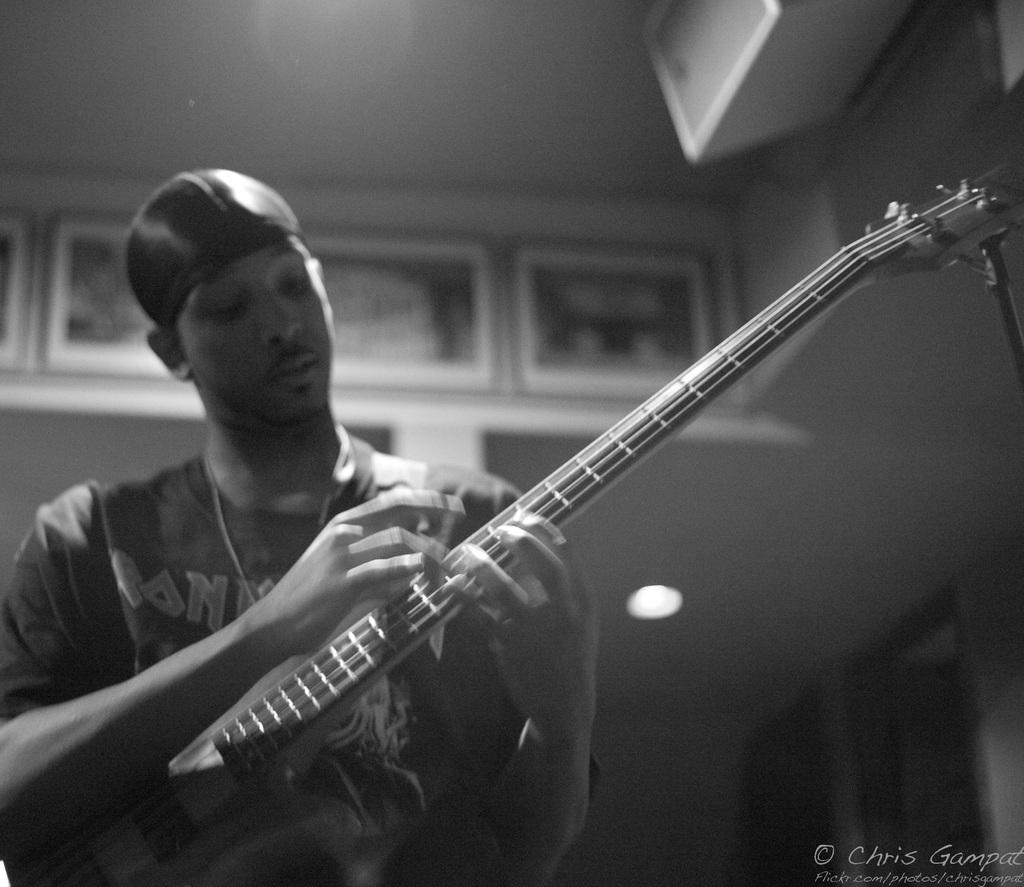What is the person in the image doing? The person is playing the guitar. What object is the person holding while playing the guitar? The person is holding a guitar. What type of headwear is the person wearing? The person is wearing a cap. What is the color of the image? The image is black in color. What part of the brain can be seen in the image? There is no part of the brain visible in the image; it features a person playing a guitar. How many fingers are visible on the person's hand in the image? The image does not show the person's fingers, only the guitar they are playing. 